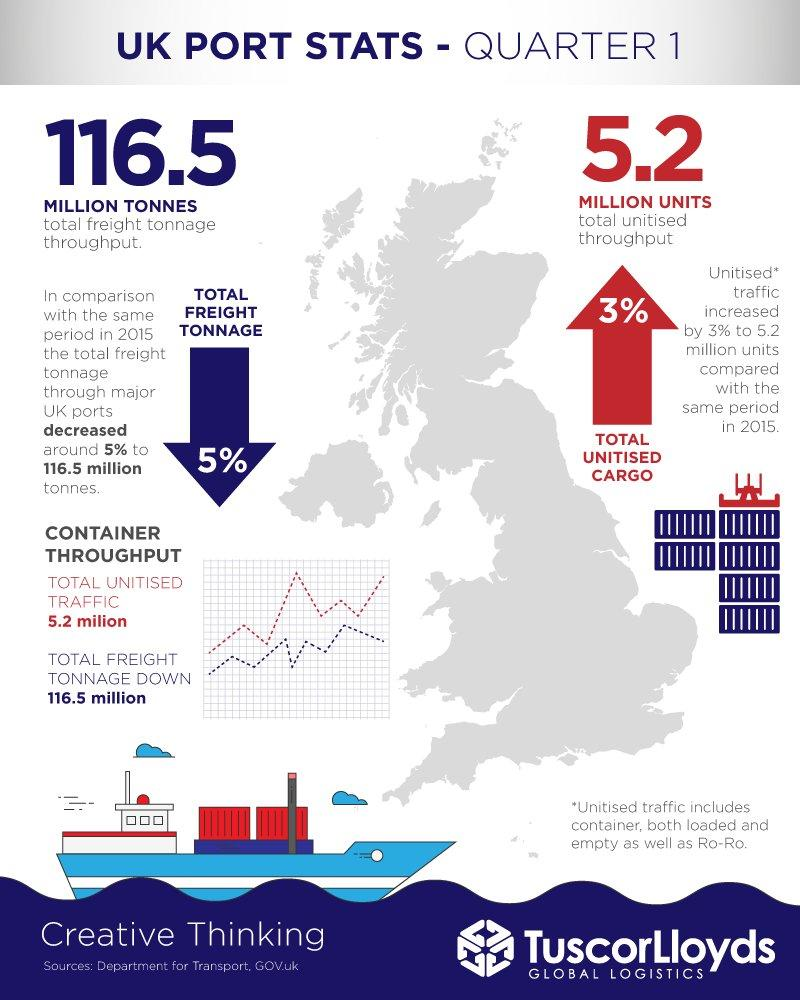List a handful of essential elements in this visual. The total throughput is 5.2 million. The total throughput is estimated to be 116.5 million tonnes. 